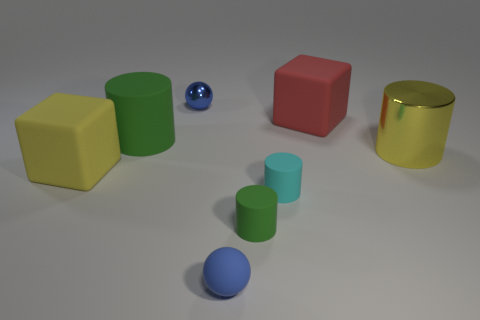Are there any big yellow things?
Make the answer very short. Yes. Are there more big yellow metallic cylinders behind the tiny blue metallic sphere than rubber objects that are behind the large yellow metallic cylinder?
Your answer should be very brief. No. What material is the tiny thing that is left of the tiny green rubber object and behind the tiny blue rubber sphere?
Offer a very short reply. Metal. Do the large yellow metal object and the tiny green object have the same shape?
Your answer should be compact. Yes. There is a rubber sphere; how many big objects are right of it?
Make the answer very short. 2. There is a cylinder that is to the right of the cyan object; does it have the same size as the big red rubber thing?
Offer a very short reply. Yes. The other small object that is the same shape as the small green thing is what color?
Provide a succinct answer. Cyan. Are there any other things that are the same shape as the red object?
Ensure brevity in your answer.  Yes. There is a cyan object that is in front of the large green rubber object; what shape is it?
Offer a terse response. Cylinder. How many small green objects are the same shape as the cyan object?
Ensure brevity in your answer.  1. 